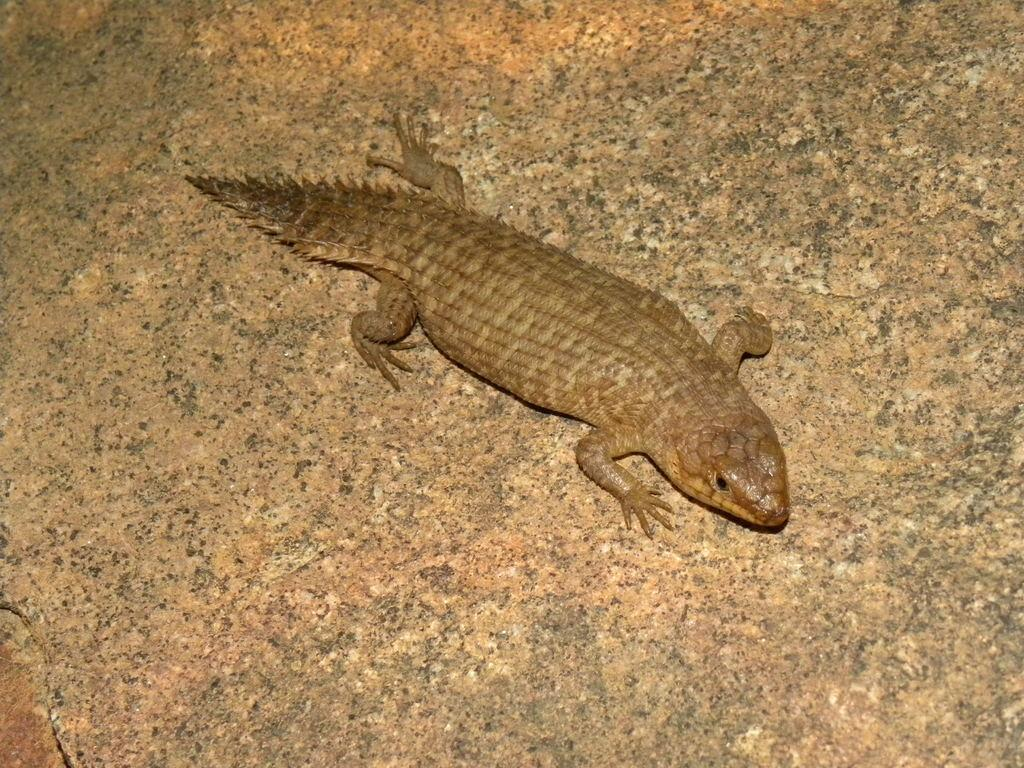What type of animal is in the image? There is a lizard in the image. What surface is the lizard on? The lizard is on granite. How many sheep are present in the image? There are no sheep present in the image; it features a lizard on granite. What type of cart is being offered by the lizard in the image? There is no cart or offer present in the image; it only features a lizard on granite. 